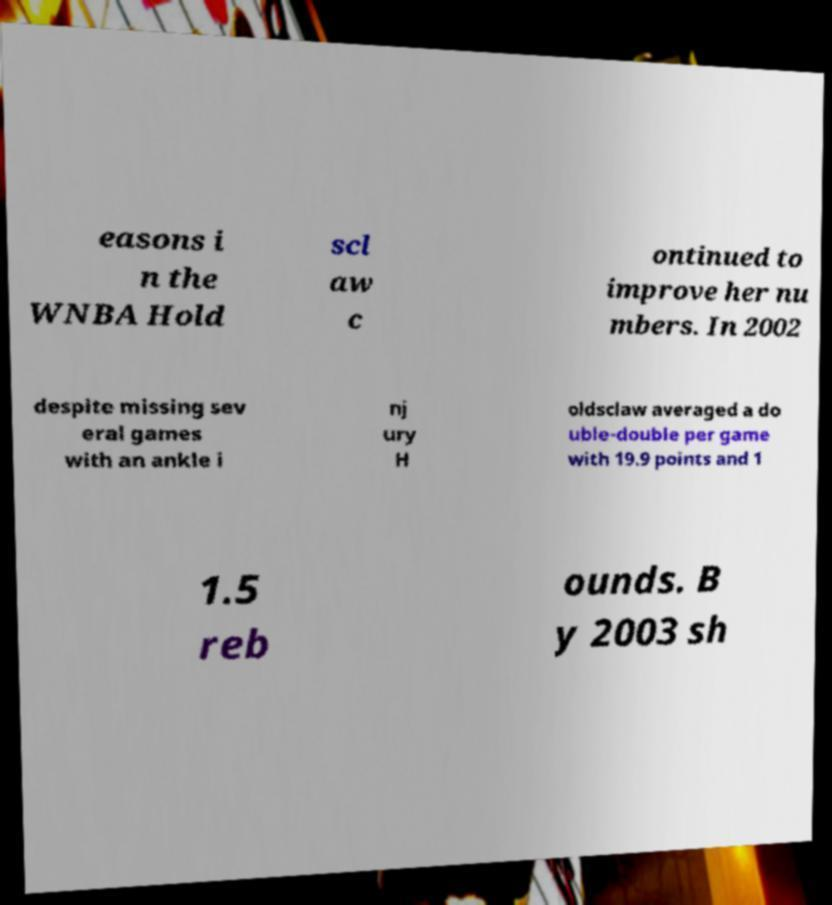There's text embedded in this image that I need extracted. Can you transcribe it verbatim? easons i n the WNBA Hold scl aw c ontinued to improve her nu mbers. In 2002 despite missing sev eral games with an ankle i nj ury H oldsclaw averaged a do uble-double per game with 19.9 points and 1 1.5 reb ounds. B y 2003 sh 